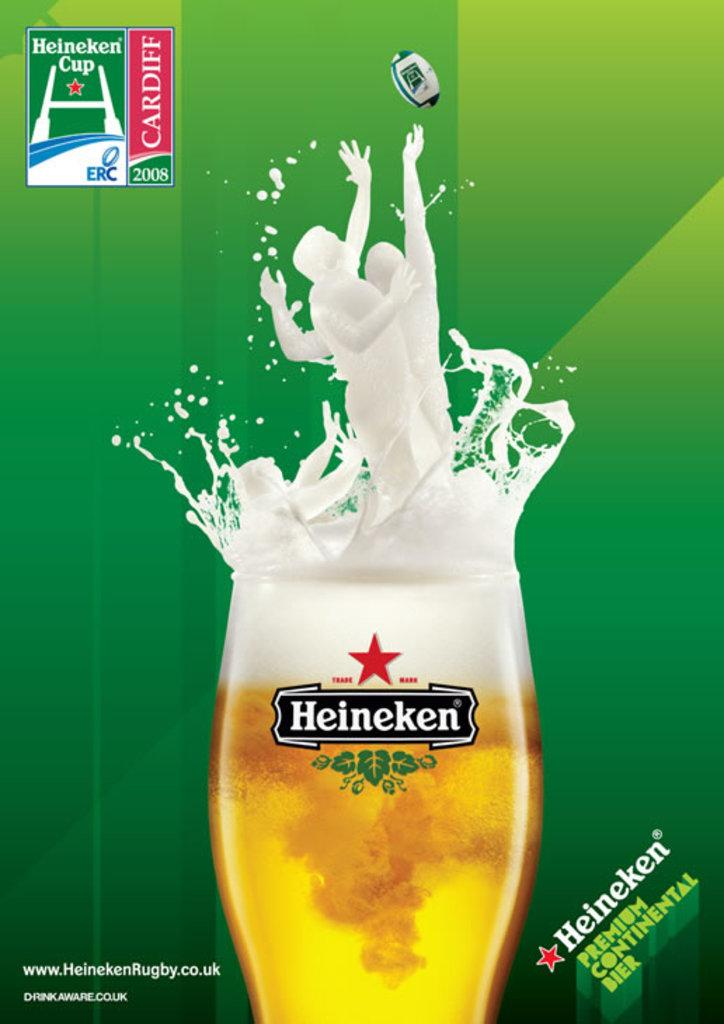<image>
Provide a brief description of the given image. A Heineken glass is filled with beer with the company being advertised around it. 